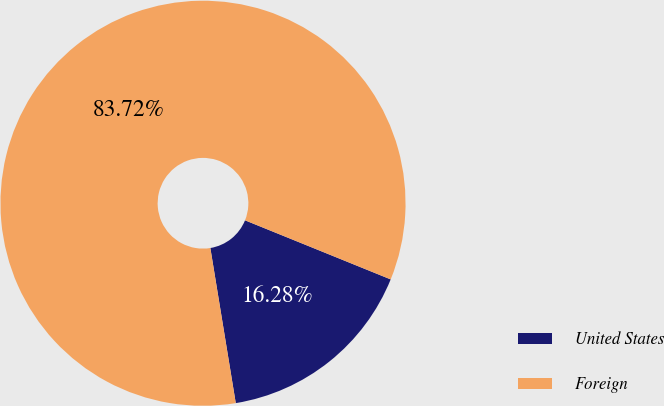Convert chart to OTSL. <chart><loc_0><loc_0><loc_500><loc_500><pie_chart><fcel>United States<fcel>Foreign<nl><fcel>16.28%<fcel>83.72%<nl></chart> 